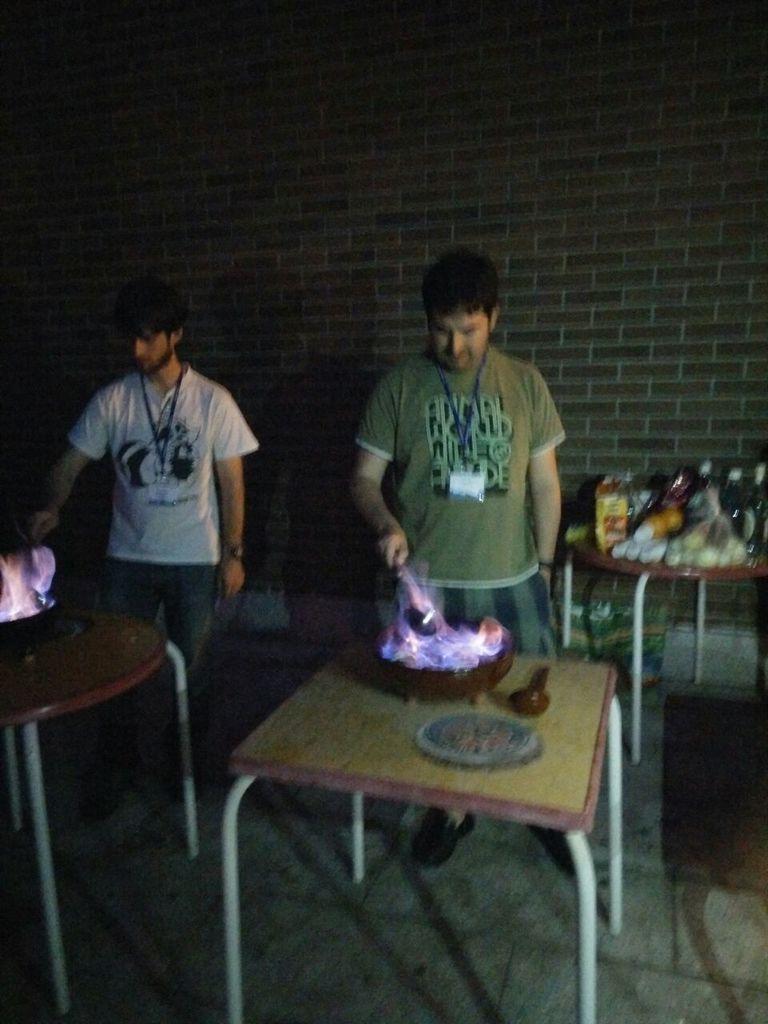Could you give a brief overview of what you see in this image? In this image we can see two men standing near the tables on the tables there are bowls with fire and an object on the table and they are holding an object and there is a table behind the man with few objects on the table and a wall in the background. 